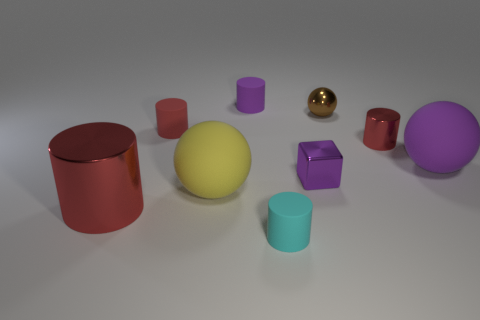What is the largest object in the scene, and how does it compare to the others? The largest object in the scene is the central yellow sphere. Its size dominates the visual field when compared to the other objects, such as the variously sized cylinders and cubes dotted around it. Besides its size, its central placement makes it a focal point, guiding the viewer’s gaze among the other items. 